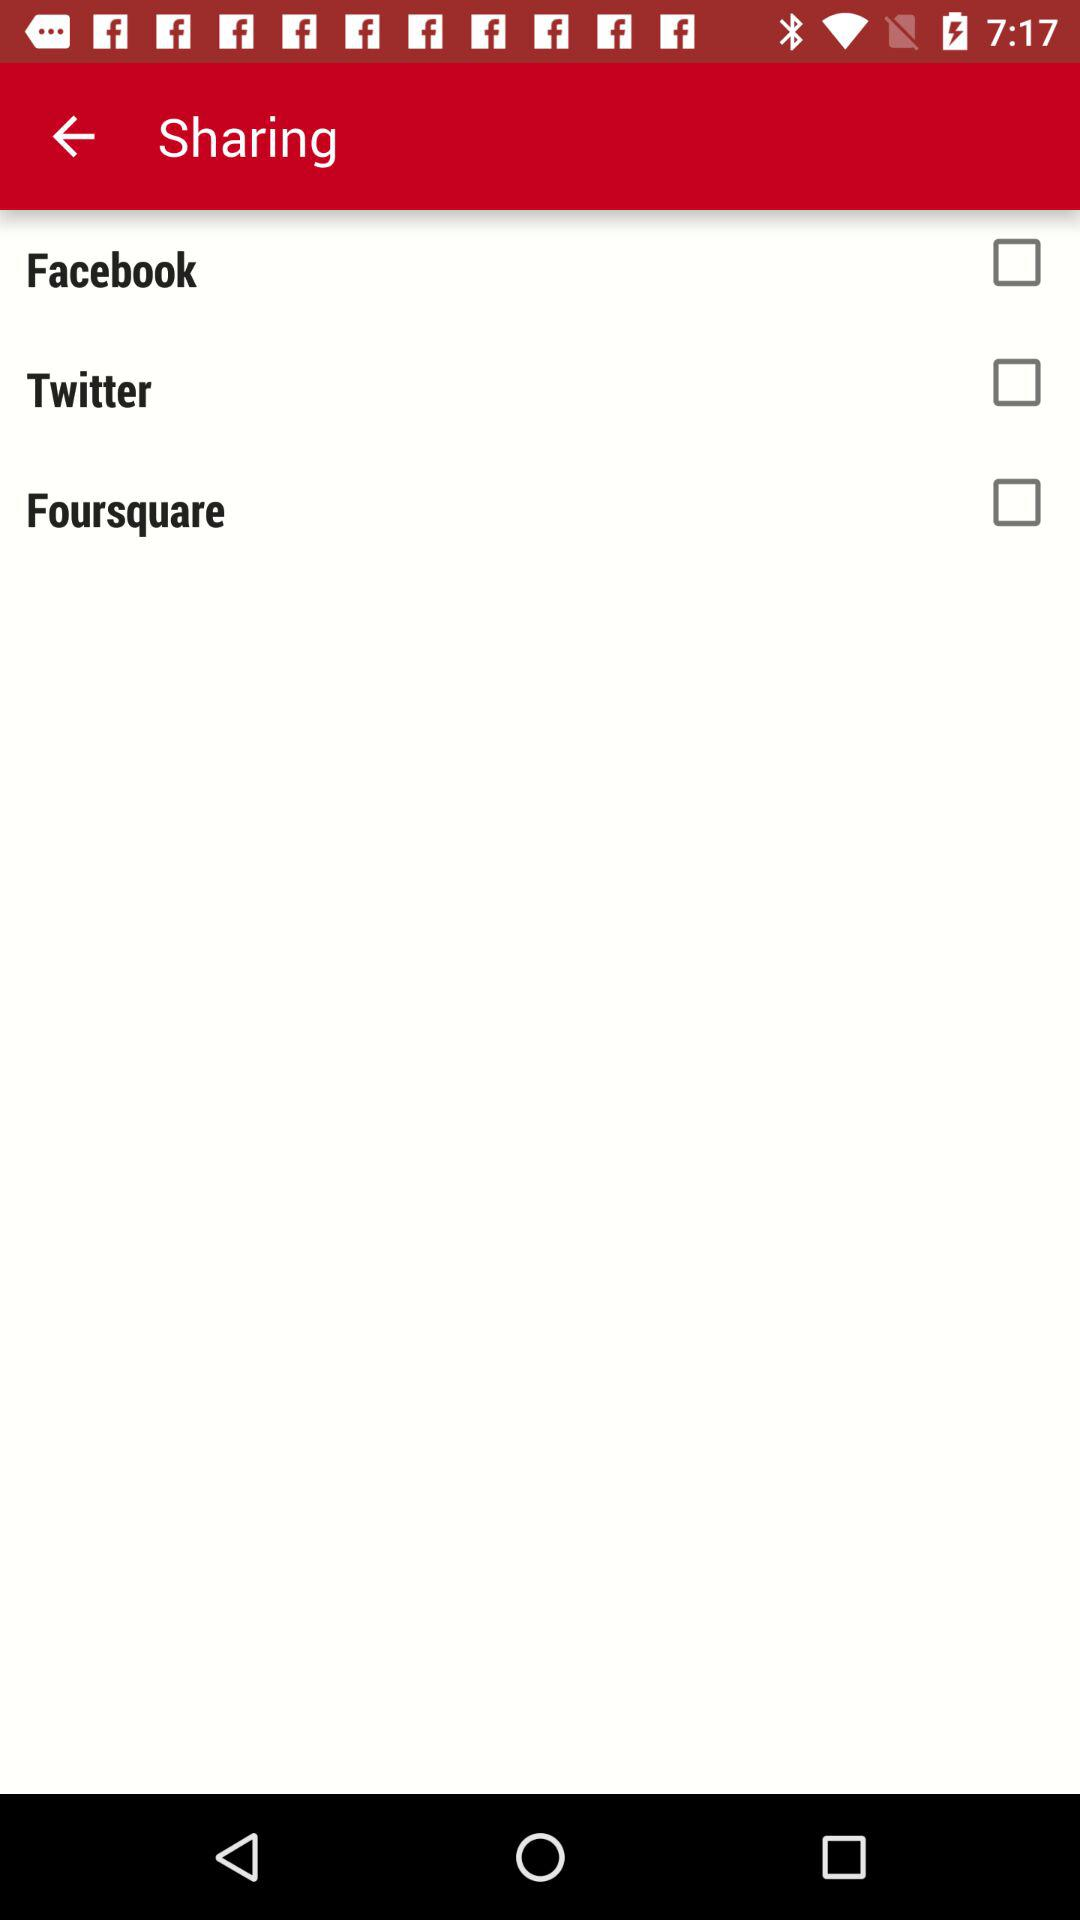What applications can be used for sharing? The applications are "Facebook", "Twitter" and "Foursquare". 